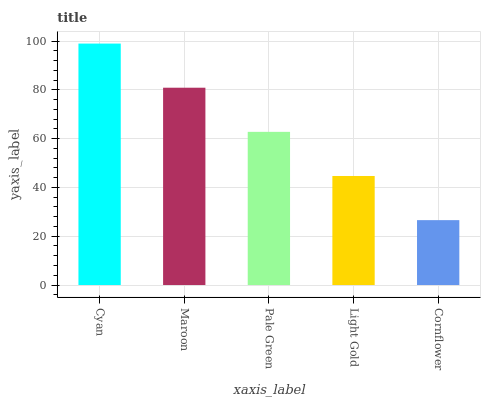Is Cornflower the minimum?
Answer yes or no. Yes. Is Cyan the maximum?
Answer yes or no. Yes. Is Maroon the minimum?
Answer yes or no. No. Is Maroon the maximum?
Answer yes or no. No. Is Cyan greater than Maroon?
Answer yes or no. Yes. Is Maroon less than Cyan?
Answer yes or no. Yes. Is Maroon greater than Cyan?
Answer yes or no. No. Is Cyan less than Maroon?
Answer yes or no. No. Is Pale Green the high median?
Answer yes or no. Yes. Is Pale Green the low median?
Answer yes or no. Yes. Is Light Gold the high median?
Answer yes or no. No. Is Cornflower the low median?
Answer yes or no. No. 